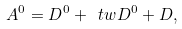Convert formula to latex. <formula><loc_0><loc_0><loc_500><loc_500>A ^ { 0 } = D ^ { 0 } + \ t w D ^ { 0 } + D ,</formula> 